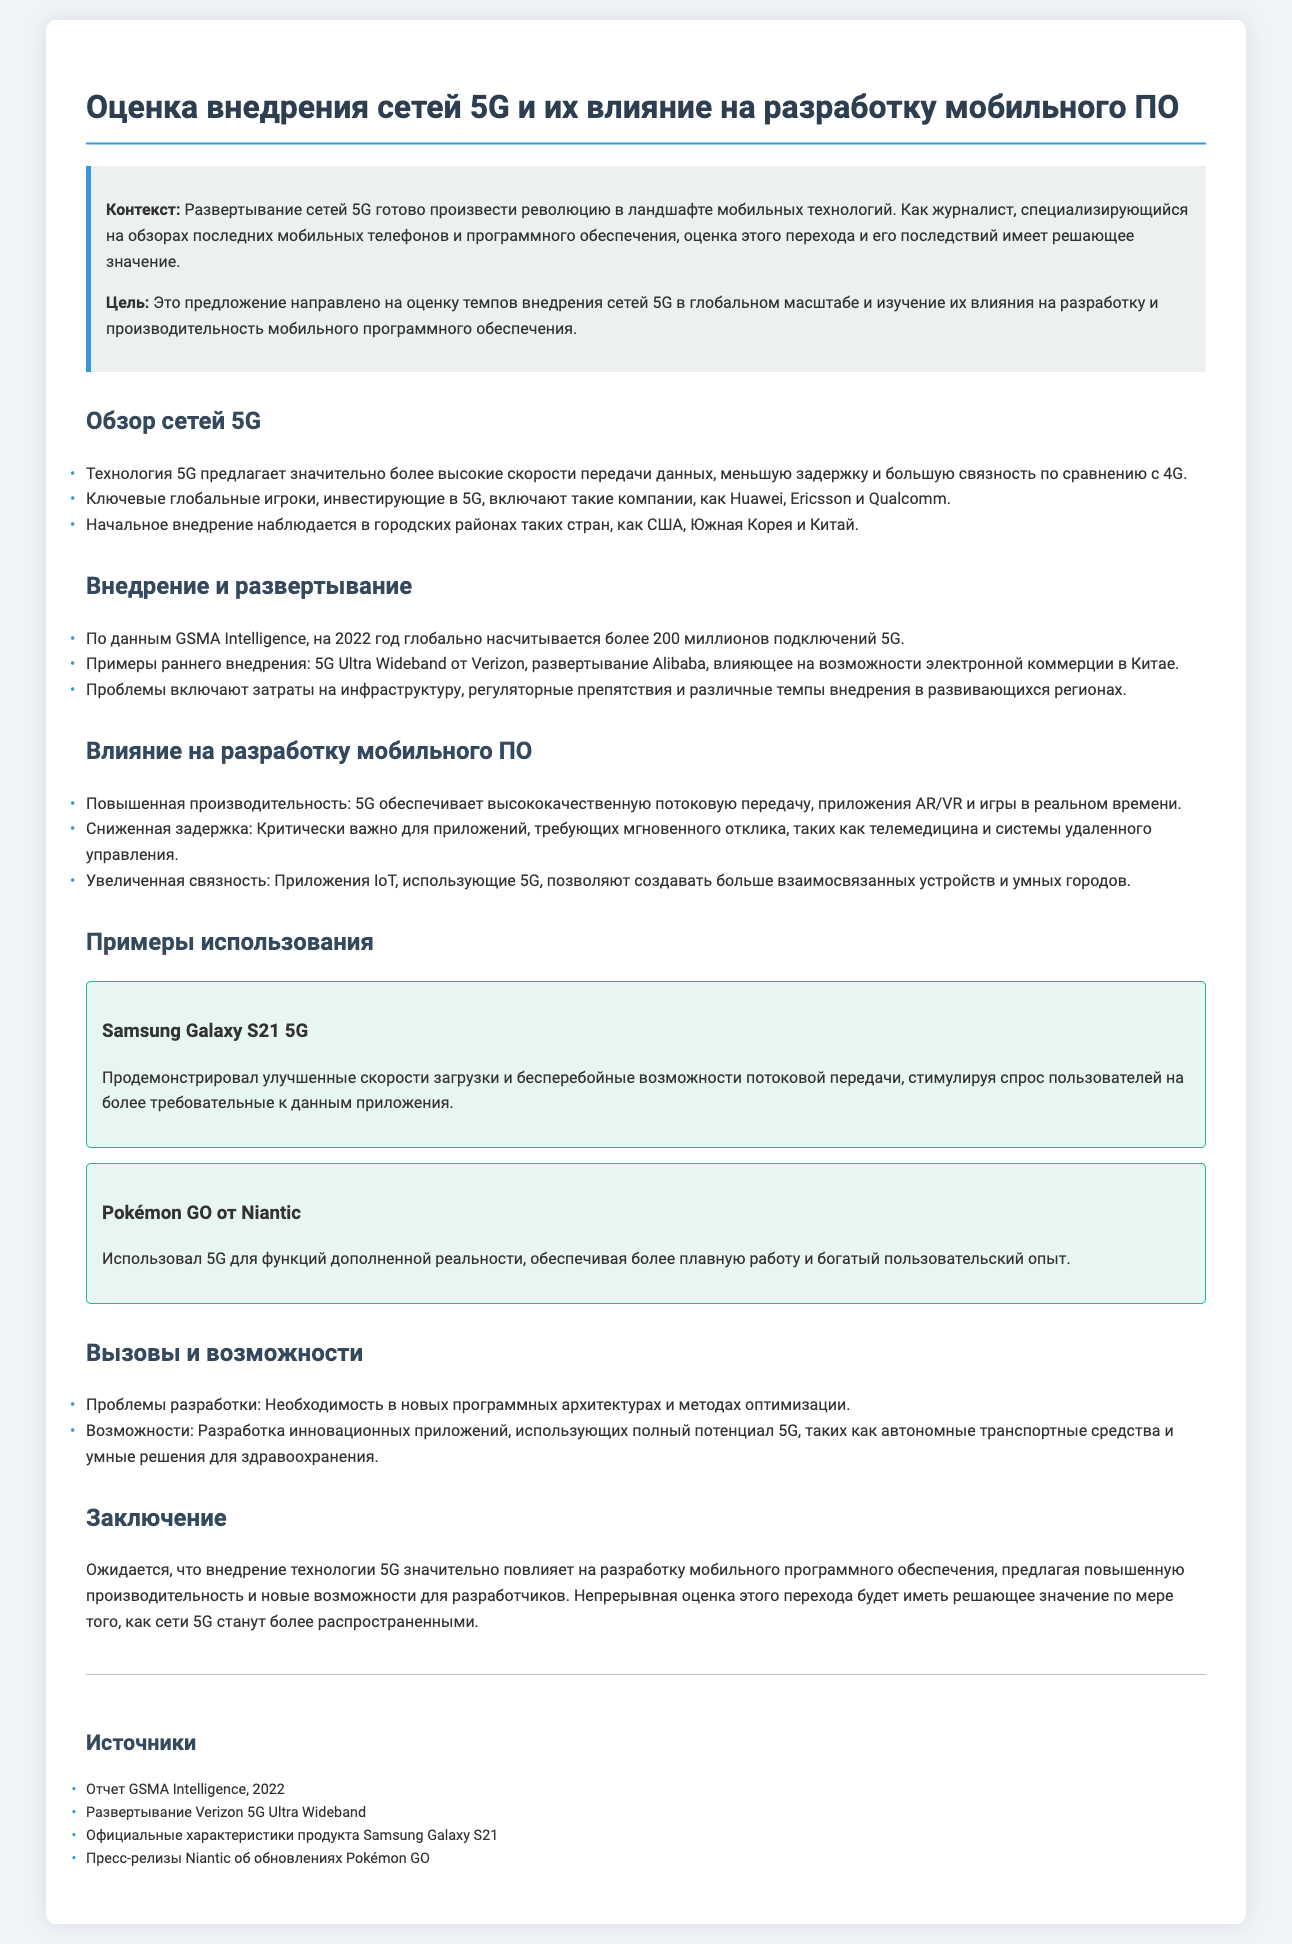Какова основная цель предложения? Основная цель предложения заключается в оценке темпов внедрения сетей 5G в глобальном масштабе и изучении их влияния на разработку и производительность мобильного программного обеспечения.
Answer: Оценка темпов внедрения сетей 5G и изучение их влияния на разработку и производительность мобильного ПО Сколько было глобальных подключений 5G на 2022 год? По данным GSMA Intelligence, на 2022 год глобально насчитывается более 200 миллионов подключений 5G.
Answer: Более 200 миллионов Какие компании являются ключевыми игроками в инвестициях 5G? Ключевыми игроками, инвестирующими в 5G, являются такие компании, как Huawei, Ericsson и Qualcomm.
Answer: Huawei, Ericsson, Qualcomm Увеличенная связность 5G позволяет создавать больше взаимосвязанных устройств и каких городов? Увеличенная связность 5G позволяет создавать больше взаимосвязанных устройств и умных городов.
Answer: Умных городов Какова ожидаемая роль технологии 5G в разработке мобильного программного обеспечения? Ожидается, что внедрение технологии 5G значительно повлияет на разработку мобильного программного обеспечения, предлагая повышенную производительность и новые возможности для разработчиков.
Answer: Значительно повлияет на разработку мобильного ПО В чем заключаются проблемы разработки, упомянутые в документе? Проблемы разработки заключаются в необходимости в новых программных архитектурах и методах оптимизации.
Answer: Новых программных архитектурах и методах оптимизации Какой случай использования 5G упоминается в документе? Упоминается случай использования Samsung Galaxy S21 5G, который демонстрирует улучшенные скорости загрузки и бесперебойные возможности потоковой передачи.
Answer: Samsung Galaxy S21 5G Кто развертывает 5G Ultra Wideband? 5G Ultra Wideband развертывает Verizon.
Answer: Verizon Каково влияние 5G на приложения AR/VR и игры в реальном времени? Влияние 5G на приложения AR/VR и игры в реальном времени заключается в повышенной производительности.
Answer: Повышенная производительность 